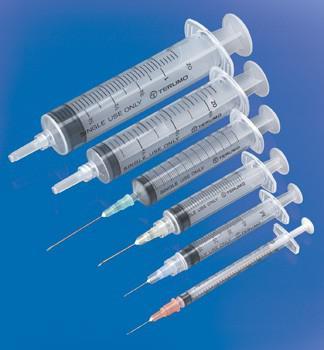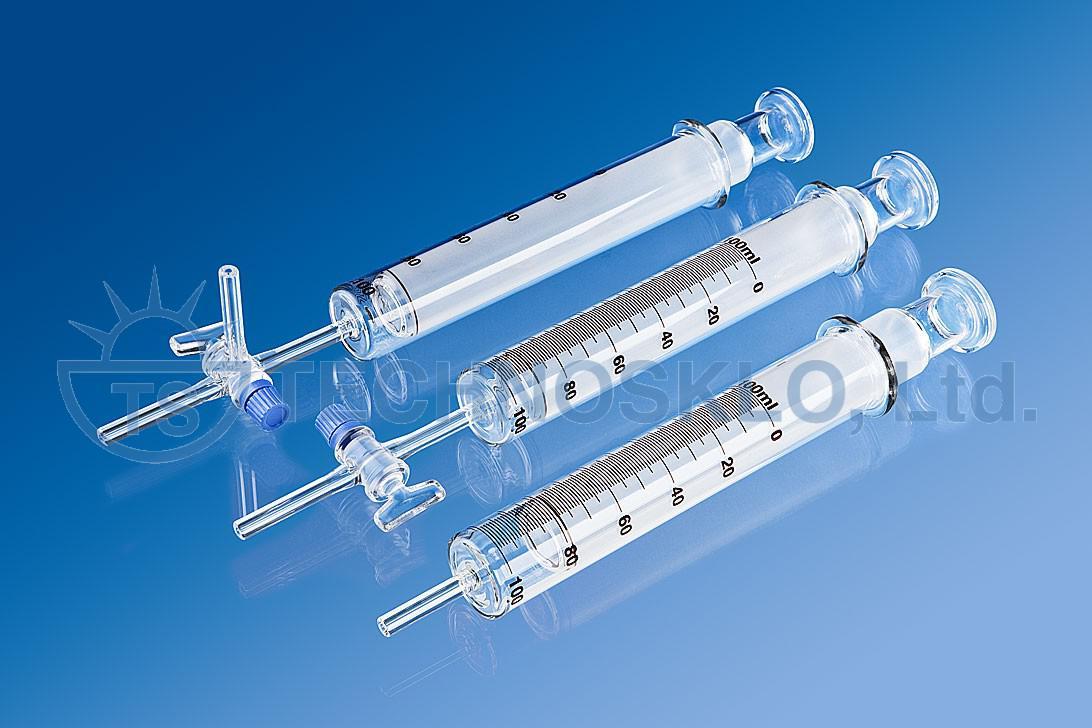The first image is the image on the left, the second image is the image on the right. Evaluate the accuracy of this statement regarding the images: "One image shows two unwrapped syringe items, arranged side-by-side at an angle.". Is it true? Answer yes or no. No. The first image is the image on the left, the second image is the image on the right. Considering the images on both sides, is "One of the images contains more than five syringes." valid? Answer yes or no. Yes. 